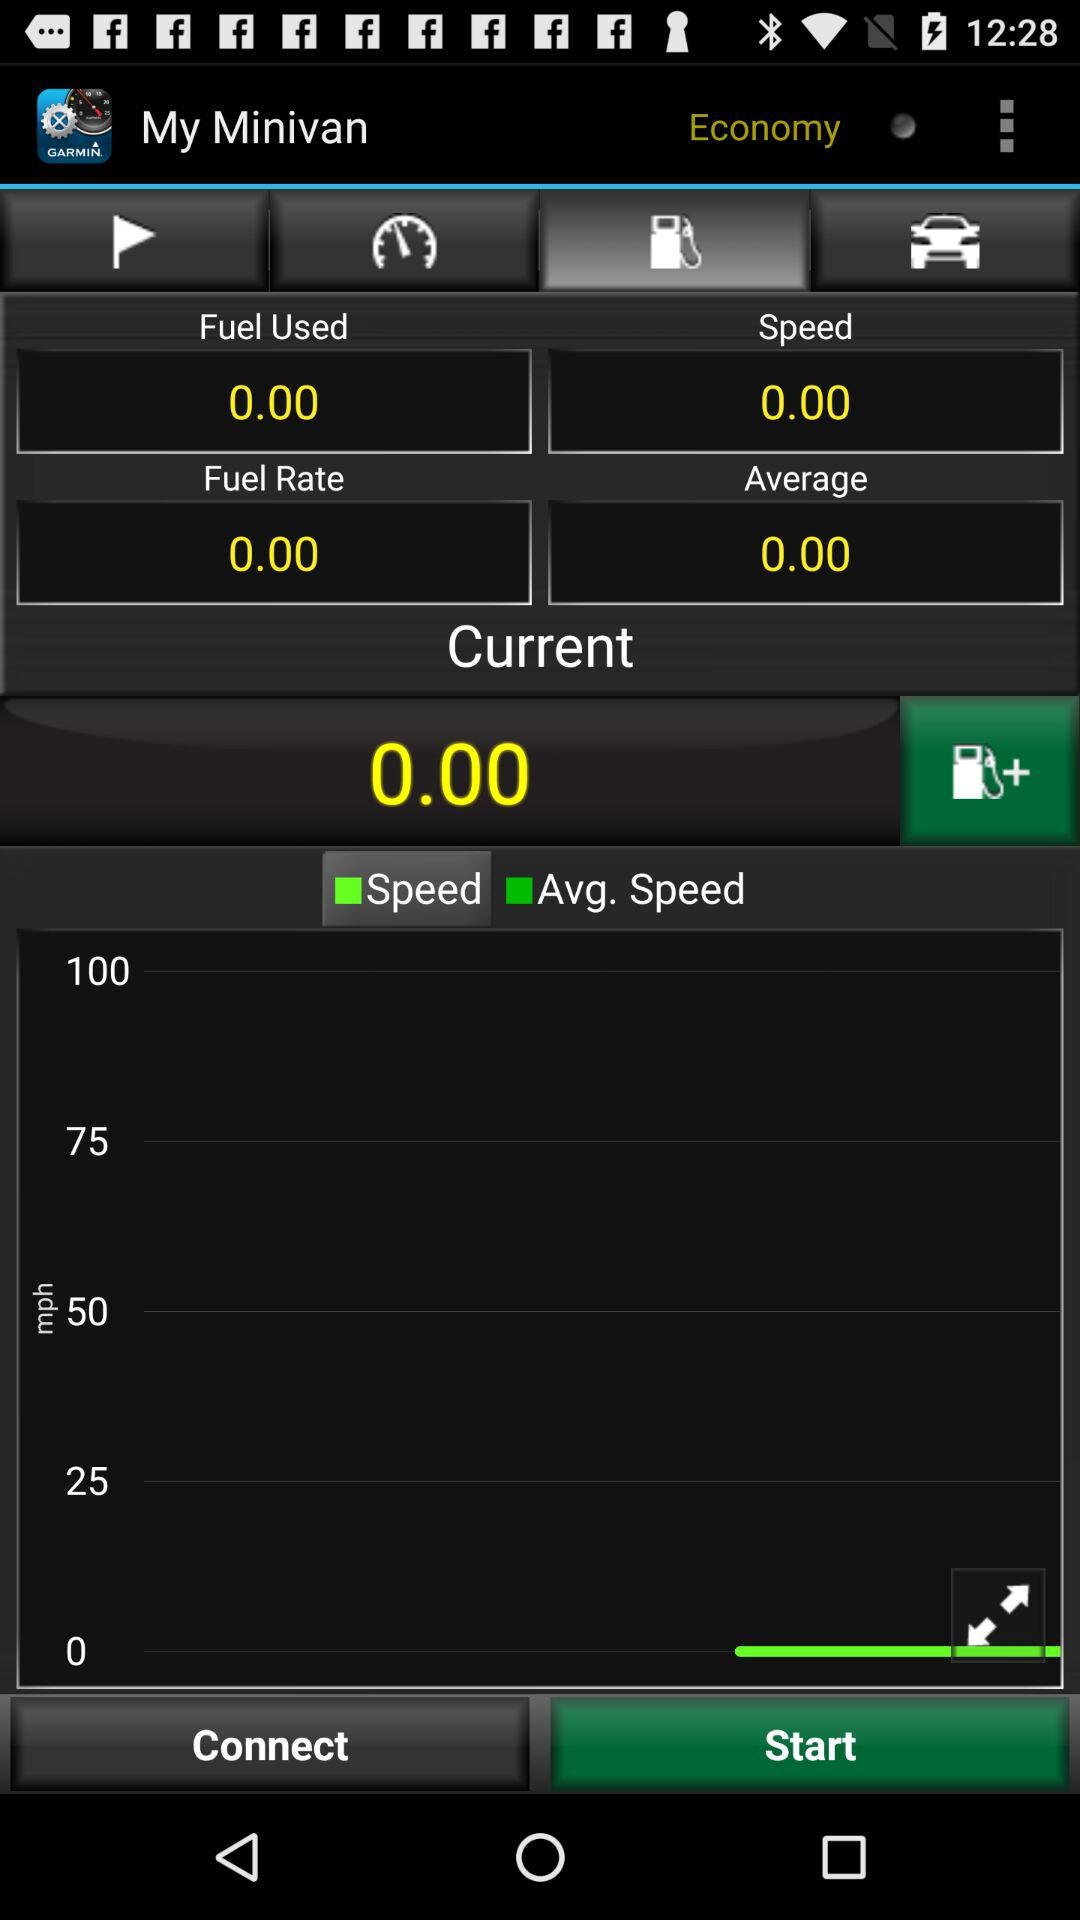What is the speed? The speed is 0. 